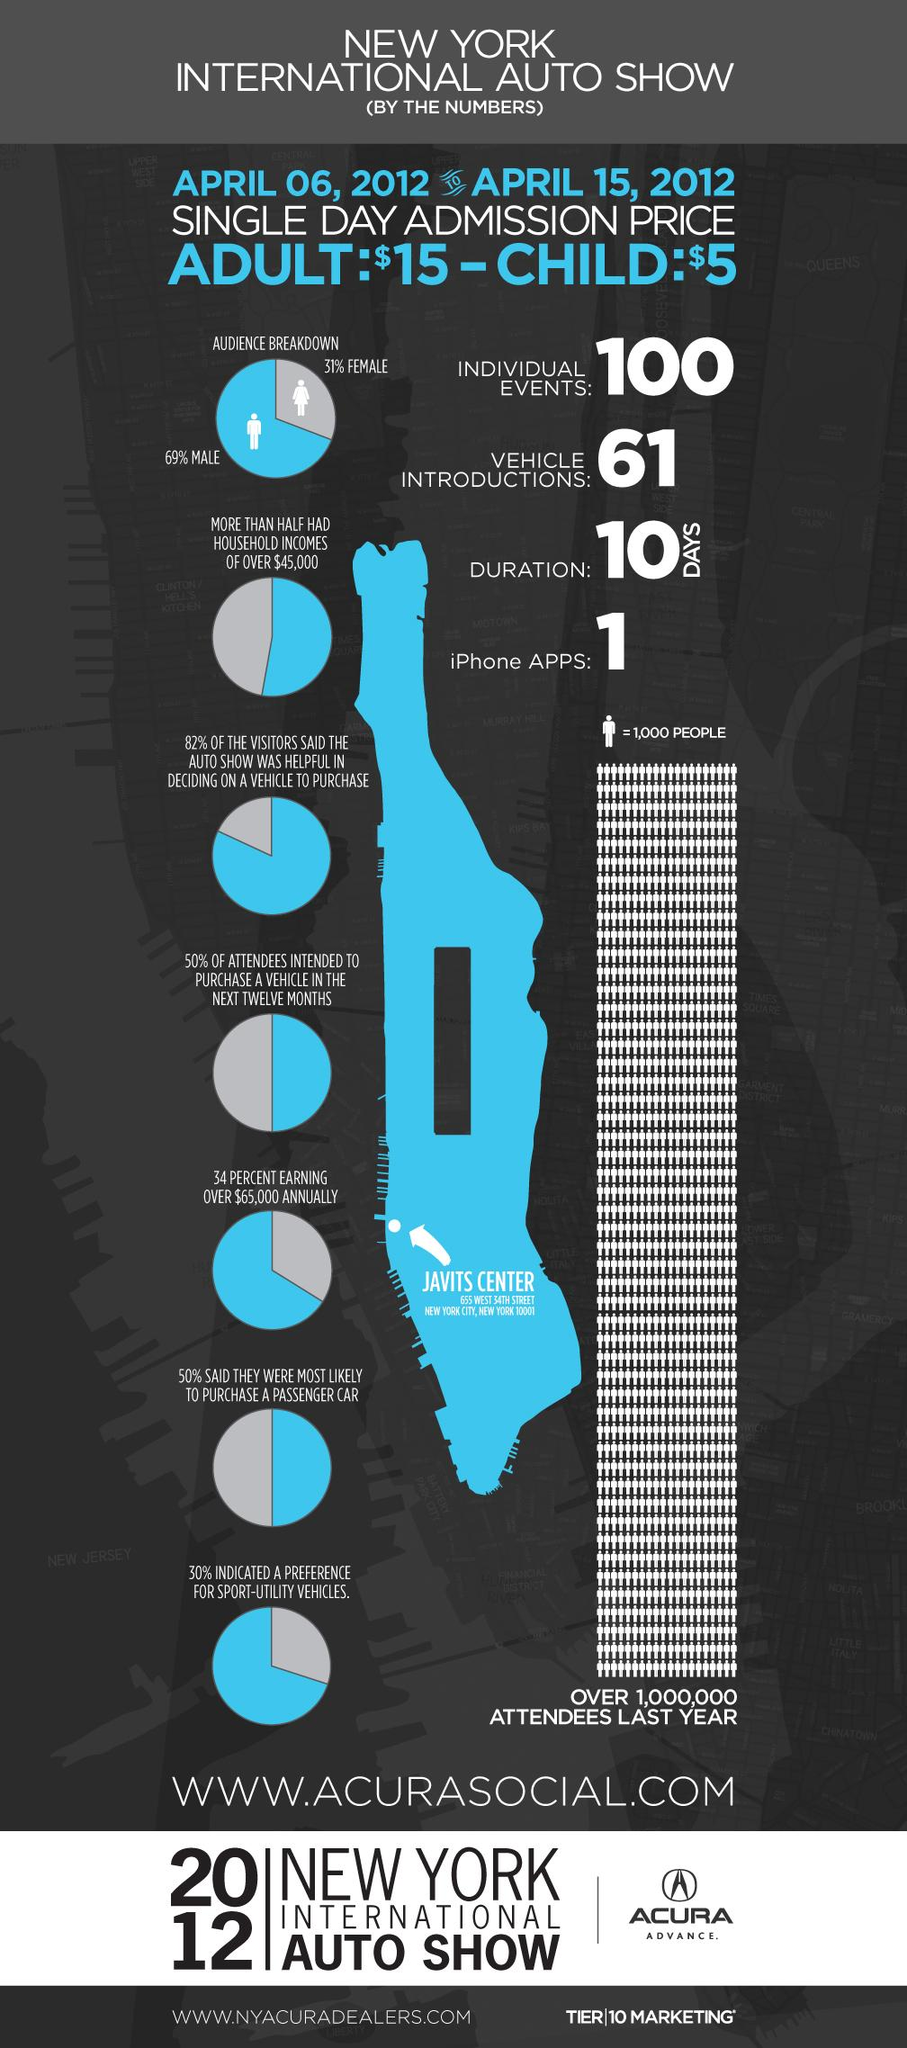Give some essential details in this illustration. The New York International Auto Show saw the introduction of 61 vehicles. The New York International Auto Show conducted in 2012 lasted for a duration of 10 days. Out of all women who attended the New York International Auto Show, 31% were present. The New York International Auto Show was attended by 69% of men. According to the survey, 18% of the visitors did not find the auto show helpful in deciding on a vehicle to purchase. 